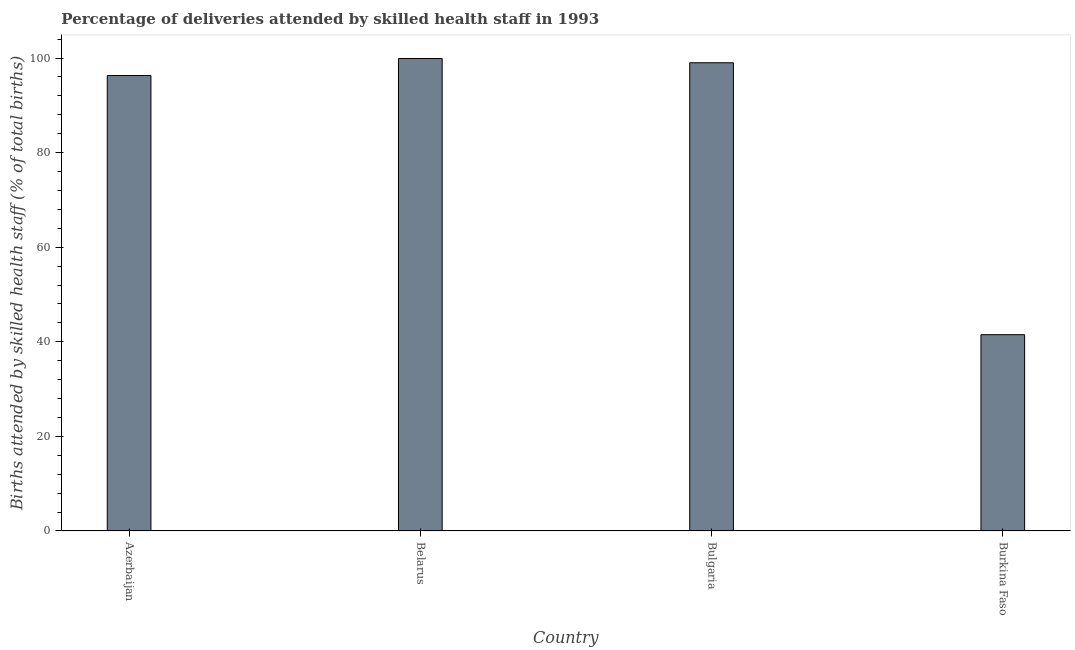Does the graph contain grids?
Keep it short and to the point. No. What is the title of the graph?
Give a very brief answer. Percentage of deliveries attended by skilled health staff in 1993. What is the label or title of the Y-axis?
Give a very brief answer. Births attended by skilled health staff (% of total births). What is the number of births attended by skilled health staff in Azerbaijan?
Provide a succinct answer. 96.3. Across all countries, what is the maximum number of births attended by skilled health staff?
Offer a very short reply. 99.9. Across all countries, what is the minimum number of births attended by skilled health staff?
Provide a short and direct response. 41.5. In which country was the number of births attended by skilled health staff maximum?
Give a very brief answer. Belarus. In which country was the number of births attended by skilled health staff minimum?
Provide a succinct answer. Burkina Faso. What is the sum of the number of births attended by skilled health staff?
Your response must be concise. 336.7. What is the difference between the number of births attended by skilled health staff in Belarus and Bulgaria?
Your answer should be compact. 0.9. What is the average number of births attended by skilled health staff per country?
Give a very brief answer. 84.17. What is the median number of births attended by skilled health staff?
Provide a short and direct response. 97.65. In how many countries, is the number of births attended by skilled health staff greater than 28 %?
Provide a succinct answer. 4. Is the number of births attended by skilled health staff in Belarus less than that in Bulgaria?
Your answer should be very brief. No. Is the difference between the number of births attended by skilled health staff in Belarus and Burkina Faso greater than the difference between any two countries?
Your answer should be very brief. Yes. What is the difference between the highest and the lowest number of births attended by skilled health staff?
Give a very brief answer. 58.4. In how many countries, is the number of births attended by skilled health staff greater than the average number of births attended by skilled health staff taken over all countries?
Your response must be concise. 3. What is the Births attended by skilled health staff (% of total births) of Azerbaijan?
Offer a very short reply. 96.3. What is the Births attended by skilled health staff (% of total births) in Belarus?
Your response must be concise. 99.9. What is the Births attended by skilled health staff (% of total births) of Bulgaria?
Provide a short and direct response. 99. What is the Births attended by skilled health staff (% of total births) in Burkina Faso?
Provide a short and direct response. 41.5. What is the difference between the Births attended by skilled health staff (% of total births) in Azerbaijan and Burkina Faso?
Make the answer very short. 54.8. What is the difference between the Births attended by skilled health staff (% of total births) in Belarus and Burkina Faso?
Your answer should be very brief. 58.4. What is the difference between the Births attended by skilled health staff (% of total births) in Bulgaria and Burkina Faso?
Offer a terse response. 57.5. What is the ratio of the Births attended by skilled health staff (% of total births) in Azerbaijan to that in Burkina Faso?
Offer a terse response. 2.32. What is the ratio of the Births attended by skilled health staff (% of total births) in Belarus to that in Bulgaria?
Make the answer very short. 1.01. What is the ratio of the Births attended by skilled health staff (% of total births) in Belarus to that in Burkina Faso?
Your response must be concise. 2.41. What is the ratio of the Births attended by skilled health staff (% of total births) in Bulgaria to that in Burkina Faso?
Make the answer very short. 2.39. 